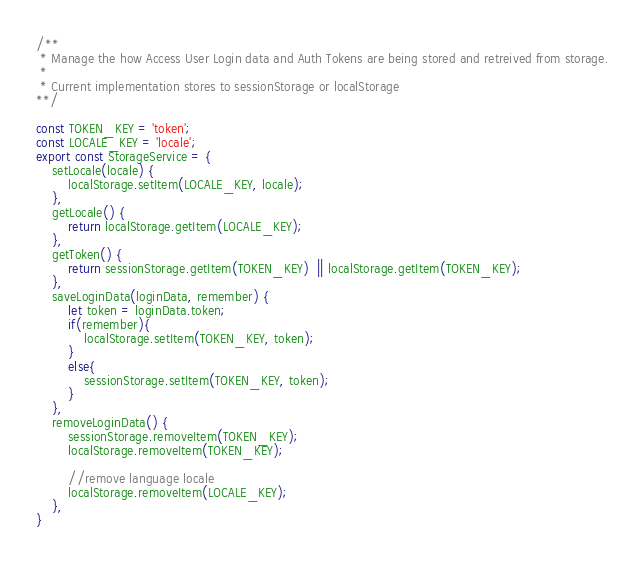<code> <loc_0><loc_0><loc_500><loc_500><_JavaScript_>/**
 * Manage the how Access User Login data and Auth Tokens are being stored and retreived from storage.
 *
 * Current implementation stores to sessionStorage or localStorage
**/

const TOKEN_KEY = 'token';
const LOCALE_KEY = 'locale';
export const StorageService = {
    setLocale(locale) {
        localStorage.setItem(LOCALE_KEY, locale);
    },
    getLocale() {
        return localStorage.getItem(LOCALE_KEY);
    },
    getToken() {
        return sessionStorage.getItem(TOKEN_KEY)  || localStorage.getItem(TOKEN_KEY);
    },
    saveLoginData(loginData, remember) {
        let token = loginData.token;
        if(remember){
            localStorage.setItem(TOKEN_KEY, token);
        }
        else{
            sessionStorage.setItem(TOKEN_KEY, token);
        }
    },
    removeLoginData() {
        sessionStorage.removeItem(TOKEN_KEY);
        localStorage.removeItem(TOKEN_KEY);

        //remove language locale
        localStorage.removeItem(LOCALE_KEY);
    },
}</code> 